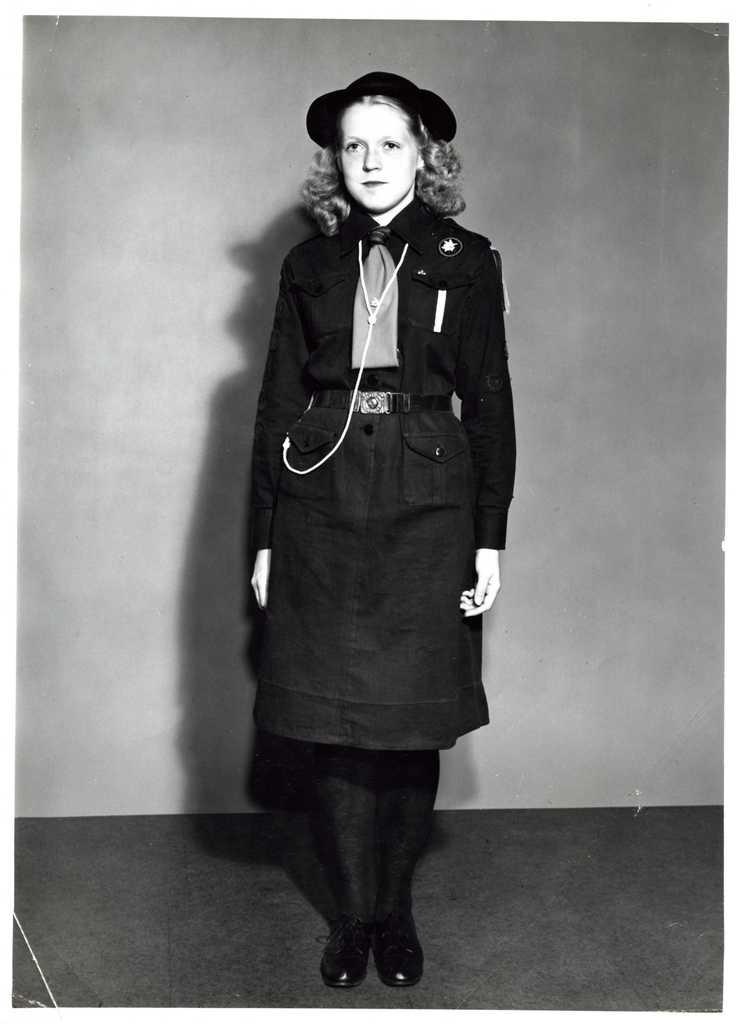What is the main subject of the image? There is a person standing in the image. What is the person wearing? The person is wearing a dress and a hat. What can be seen in the background of the image? There is a wall visible in the background of the image. What is the color scheme of the image? The image is black and white. Are there any fairies visible in the image? No, there are no fairies present in the image. What type of shame is the person experiencing in the image? There is no indication of shame in the image; the person is simply standing and wearing a dress and hat. 